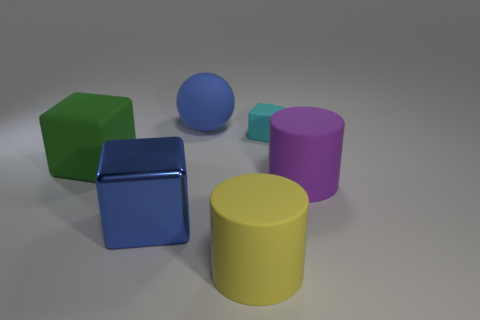Is there any other thing that is the same material as the big blue cube?
Your answer should be very brief. No. What is the size of the matte object that is both left of the yellow cylinder and on the right side of the blue metal cube?
Keep it short and to the point. Large. What number of yellow cylinders are left of the matte thing that is on the left side of the blue object behind the metal block?
Your answer should be compact. 0. Are there any rubber blocks that have the same color as the rubber sphere?
Offer a terse response. No. There is another block that is the same size as the blue metallic block; what color is it?
Ensure brevity in your answer.  Green. The big blue object in front of the rubber cube to the left of the cylinder that is on the left side of the small matte block is what shape?
Provide a short and direct response. Cube. There is a large rubber cylinder that is behind the metallic cube; what number of yellow rubber cylinders are left of it?
Ensure brevity in your answer.  1. Does the big thing that is left of the big blue metal cube have the same shape as the large rubber object that is in front of the shiny thing?
Ensure brevity in your answer.  No. There is a large purple cylinder; what number of large rubber cylinders are in front of it?
Provide a succinct answer. 1. Do the big blue thing that is in front of the large green matte block and the cyan block have the same material?
Keep it short and to the point. No. 